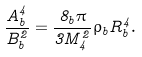Convert formula to latex. <formula><loc_0><loc_0><loc_500><loc_500>\frac { A _ { b } ^ { 4 } } { B _ { b } ^ { 2 } } = \frac { 8 _ { b } \pi } { 3 M ^ { 2 } _ { 4 } } \rho _ { b } R _ { b } ^ { 4 } .</formula> 